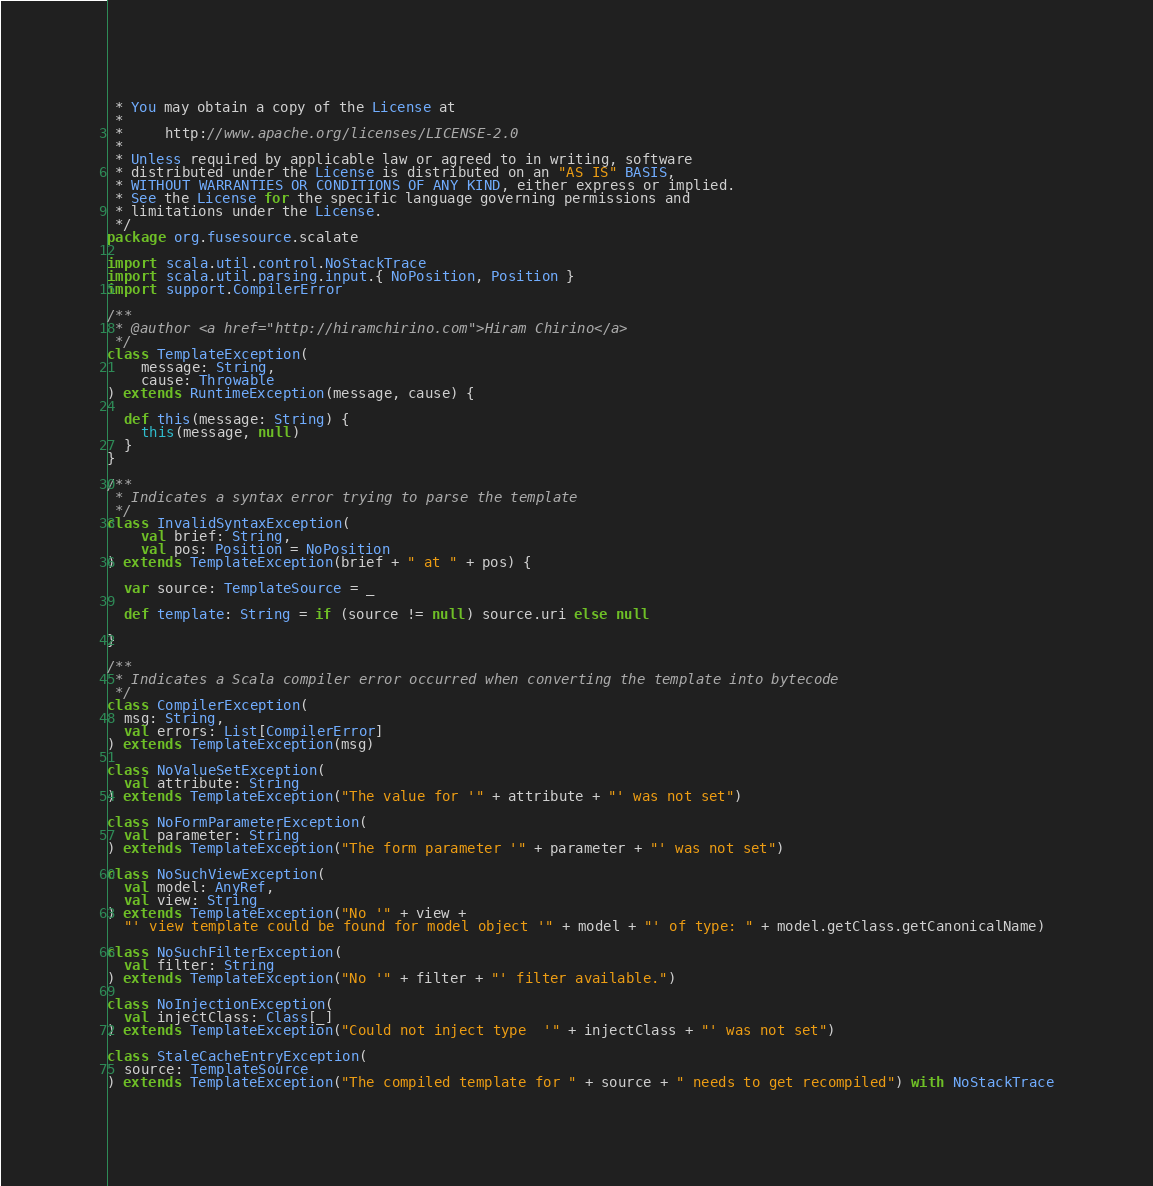<code> <loc_0><loc_0><loc_500><loc_500><_Scala_> * You may obtain a copy of the License at
 *
 *     http://www.apache.org/licenses/LICENSE-2.0
 *
 * Unless required by applicable law or agreed to in writing, software
 * distributed under the License is distributed on an "AS IS" BASIS,
 * WITHOUT WARRANTIES OR CONDITIONS OF ANY KIND, either express or implied.
 * See the License for the specific language governing permissions and
 * limitations under the License.
 */
package org.fusesource.scalate

import scala.util.control.NoStackTrace
import scala.util.parsing.input.{ NoPosition, Position }
import support.CompilerError

/**
 * @author <a href="http://hiramchirino.com">Hiram Chirino</a>
 */
class TemplateException(
    message: String,
    cause: Throwable
) extends RuntimeException(message, cause) {

  def this(message: String) {
    this(message, null)
  }
}

/**
 * Indicates a syntax error trying to parse the template
 */
class InvalidSyntaxException(
    val brief: String,
    val pos: Position = NoPosition
) extends TemplateException(brief + " at " + pos) {

  var source: TemplateSource = _

  def template: String = if (source != null) source.uri else null

}

/**
 * Indicates a Scala compiler error occurred when converting the template into bytecode
 */
class CompilerException(
  msg: String,
  val errors: List[CompilerError]
) extends TemplateException(msg)

class NoValueSetException(
  val attribute: String
) extends TemplateException("The value for '" + attribute + "' was not set")

class NoFormParameterException(
  val parameter: String
) extends TemplateException("The form parameter '" + parameter + "' was not set")

class NoSuchViewException(
  val model: AnyRef,
  val view: String
) extends TemplateException("No '" + view +
  "' view template could be found for model object '" + model + "' of type: " + model.getClass.getCanonicalName)

class NoSuchFilterException(
  val filter: String
) extends TemplateException("No '" + filter + "' filter available.")

class NoInjectionException(
  val injectClass: Class[_]
) extends TemplateException("Could not inject type  '" + injectClass + "' was not set")

class StaleCacheEntryException(
  source: TemplateSource
) extends TemplateException("The compiled template for " + source + " needs to get recompiled") with NoStackTrace
</code> 